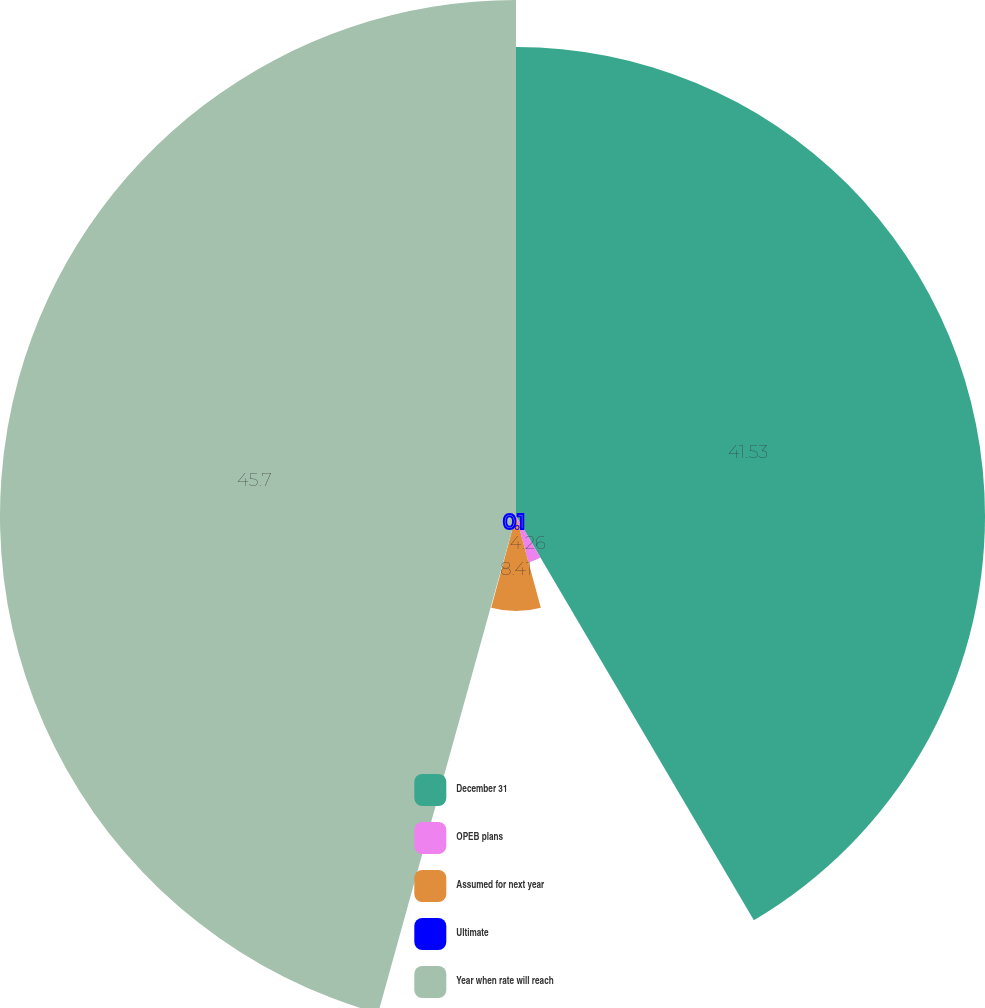<chart> <loc_0><loc_0><loc_500><loc_500><pie_chart><fcel>December 31<fcel>OPEB plans<fcel>Assumed for next year<fcel>Ultimate<fcel>Year when rate will reach<nl><fcel>41.53%<fcel>4.26%<fcel>8.41%<fcel>0.1%<fcel>45.69%<nl></chart> 